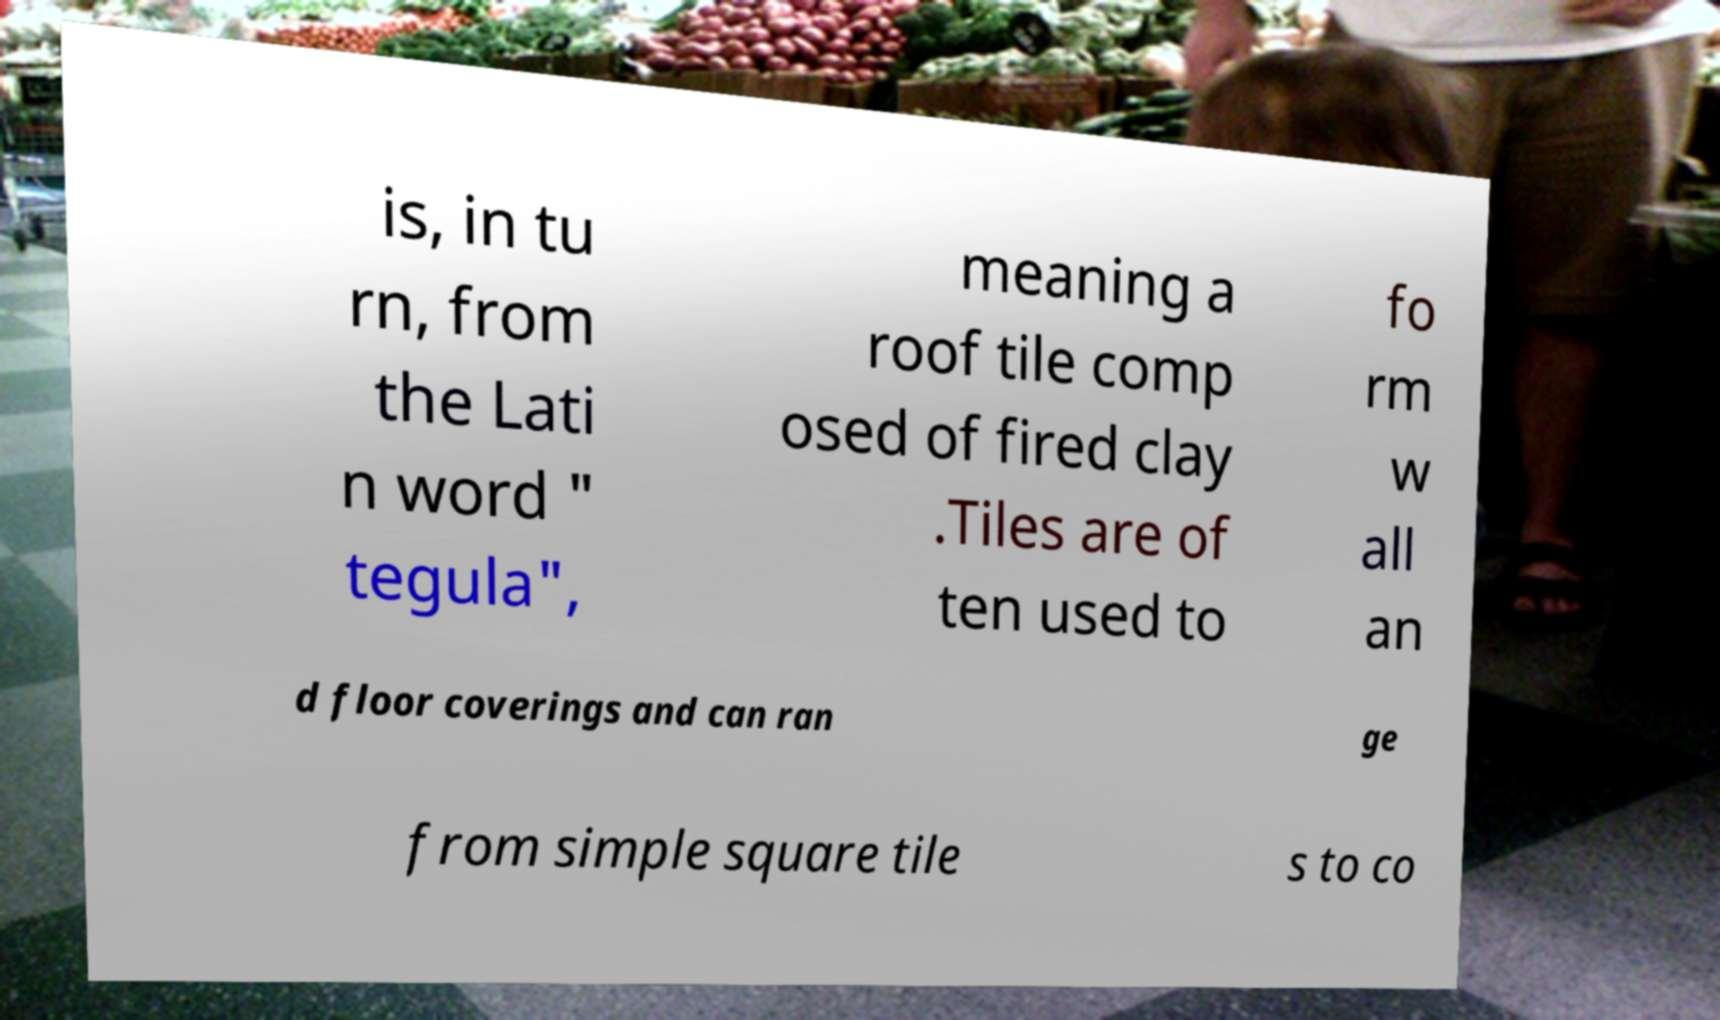Could you assist in decoding the text presented in this image and type it out clearly? is, in tu rn, from the Lati n word " tegula", meaning a roof tile comp osed of fired clay .Tiles are of ten used to fo rm w all an d floor coverings and can ran ge from simple square tile s to co 